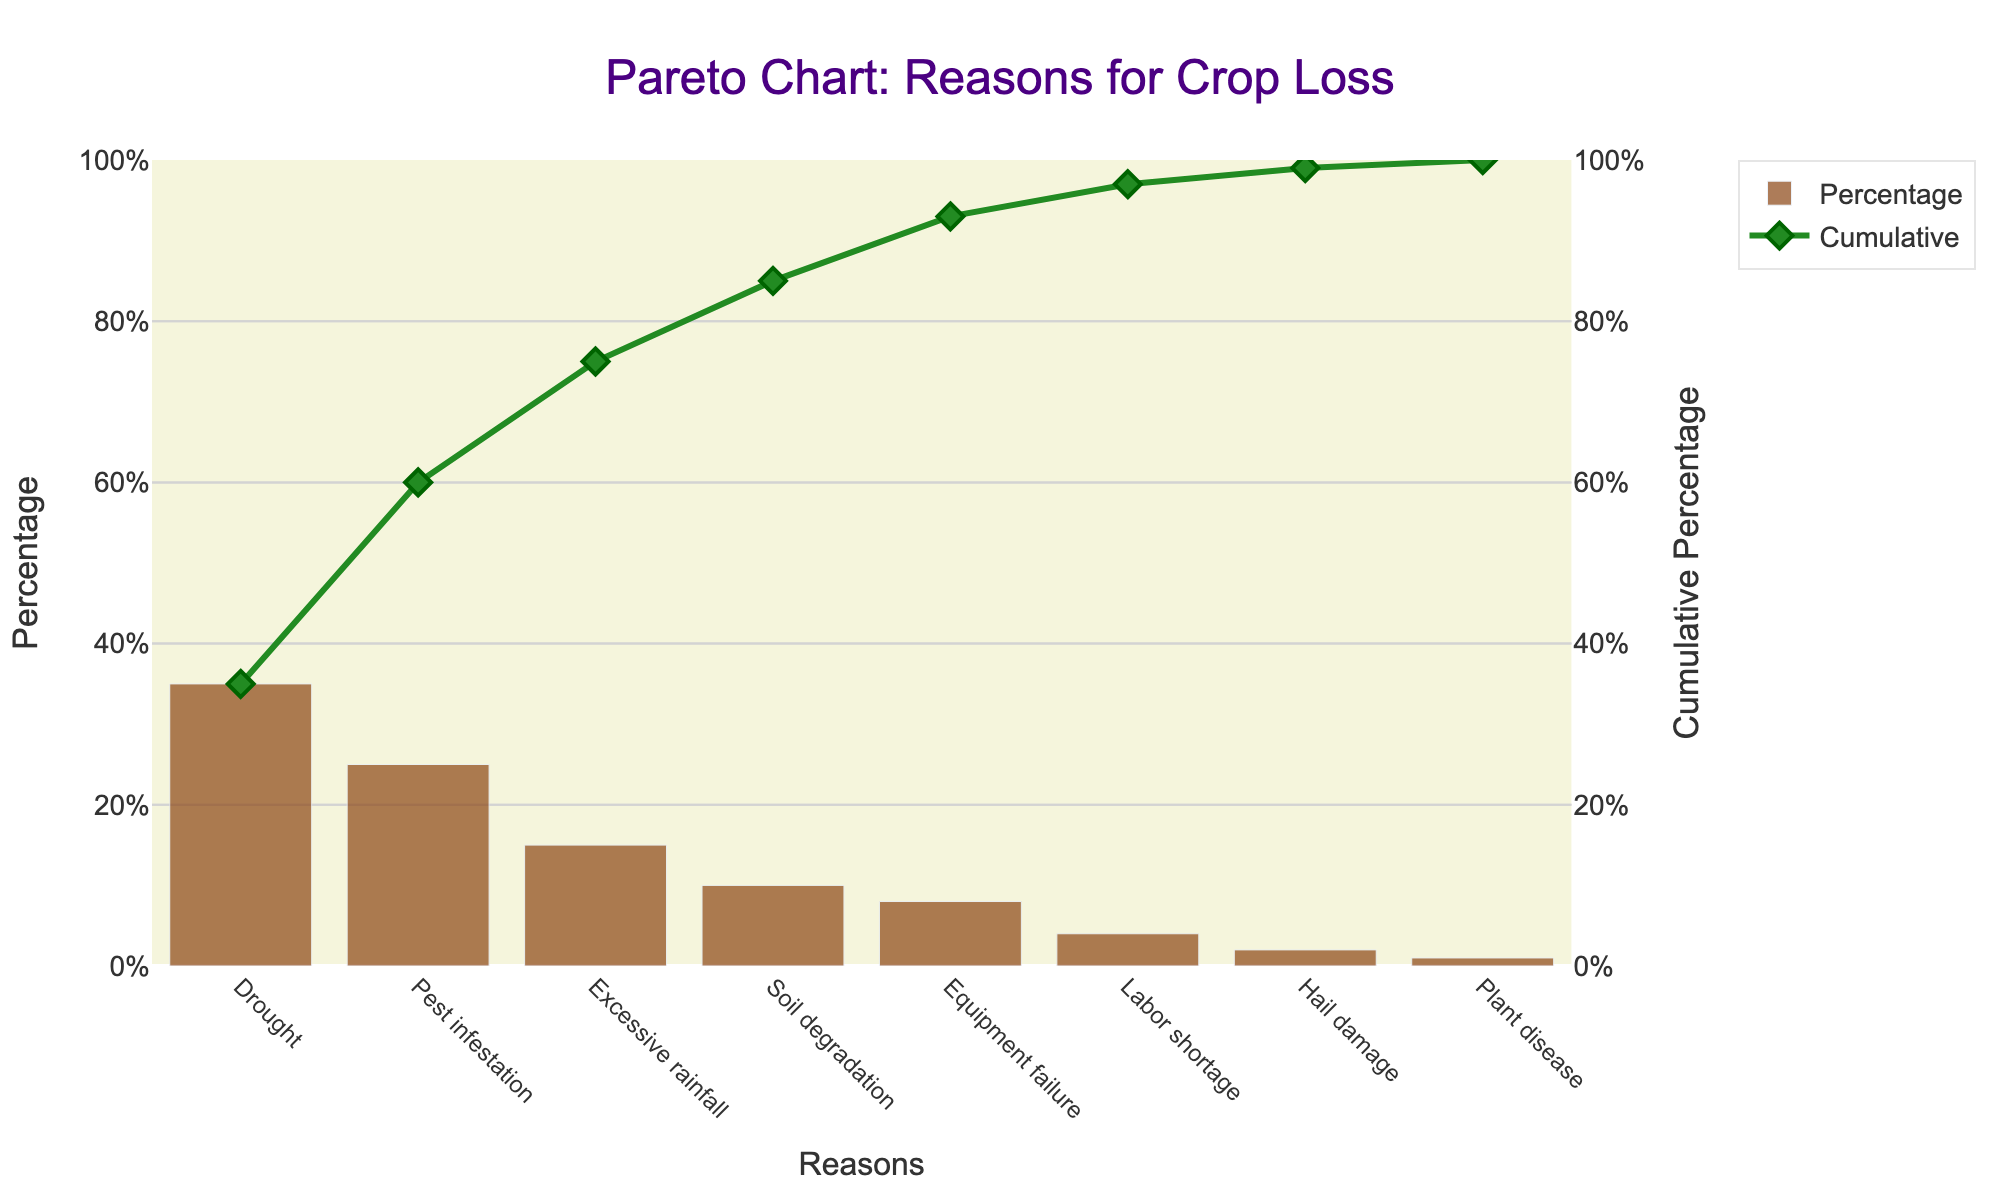What is the main title of the figure? The figure's title can be found at the top of the chart. It reads "Pareto Chart: Reasons for Crop Loss".
Answer: Pareto Chart: Reasons for Crop Loss Which reason accounts for the highest percentage of crop loss? By looking at the height of the bars in the chart, the tallest bar represents the reason with the highest percentage. In this case, "Drought" has the tallest bar.
Answer: Drought What is the cumulative percentage of crop loss after accounting for Drought and Pest infestation? The cumulative percentage can be found at each point of the line graph on the secondary y-axis. After Drought (35%) and Pest infestation (25%), the cumulative percentage is 60%.
Answer: 60% Which two reasons combined account for almost half of the crop loss? By checking the percentages or observing the bars, adding 35% (Drought) and 25% (Pest infestation) results in 60%, which exceeds half. Therefore, one must look for percentages closer to 50%. Drought (35%) and Excessive rainfall (15%) combined account for exactly 50%.
Answer: Drought and Excessive rainfall How does the percentage of crop loss from Soil degradation compare to that from Equipment failure? Observing the height of the bars for each reason, Soil degradation accounts for 10% of crop loss while Equipment failure accounts for 8%. Comparatively, Soil degradation is higher.
Answer: Soil degradation is higher What is the cumulative percentage of crop loss by the time we account for Soil degradation? The cumulative percentage line chart indicates the cumulative percentage at different points. After Soil degradation (the fourth bar), the cumulative percentage is 85% (35% + 25% + 15% + 10%).
Answer: 85% Which reasons for crop loss are responsible for less than 5% of total loss? The height of the bars indicates the percentage. Reasons with bars less than 5% are Labor shortage (4%), Hail damage (2%), and Plant disease (1%).
Answer: Labor shortage, Hail damage, Plant disease What percentage of crop loss is attributed to Hail damage? The height of the bar labeled "Hail damage" represents its percentage of crop loss, which is at 2%.
Answer: 2% What is the total percentage of crop loss accounted for by the top three reasons? Summing the percentages of the top three reasons: Drought (35%), Pest infestation (25%), and Excessive rainfall (15%) gives a total of 75%.
Answer: 75% Is the percentage of crop loss from Excessive rainfall more or less than half of that from Drought? Drought accounts for 35% and Excessive rainfall accounts for 15%. Comparing these, 15% is less than half of 35%.
Answer: Less 